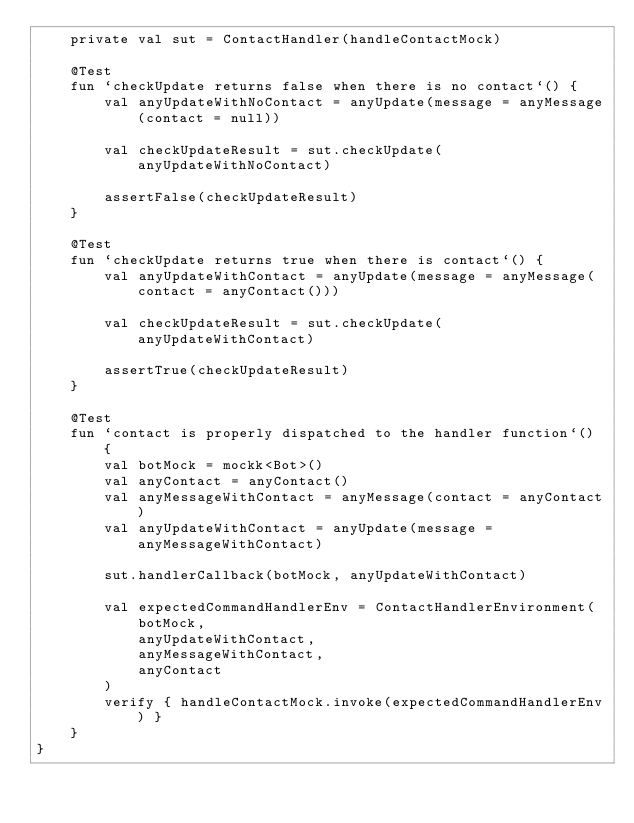Convert code to text. <code><loc_0><loc_0><loc_500><loc_500><_Kotlin_>    private val sut = ContactHandler(handleContactMock)

    @Test
    fun `checkUpdate returns false when there is no contact`() {
        val anyUpdateWithNoContact = anyUpdate(message = anyMessage(contact = null))

        val checkUpdateResult = sut.checkUpdate(anyUpdateWithNoContact)

        assertFalse(checkUpdateResult)
    }

    @Test
    fun `checkUpdate returns true when there is contact`() {
        val anyUpdateWithContact = anyUpdate(message = anyMessage(contact = anyContact()))

        val checkUpdateResult = sut.checkUpdate(anyUpdateWithContact)

        assertTrue(checkUpdateResult)
    }

    @Test
    fun `contact is properly dispatched to the handler function`() {
        val botMock = mockk<Bot>()
        val anyContact = anyContact()
        val anyMessageWithContact = anyMessage(contact = anyContact)
        val anyUpdateWithContact = anyUpdate(message = anyMessageWithContact)

        sut.handlerCallback(botMock, anyUpdateWithContact)

        val expectedCommandHandlerEnv = ContactHandlerEnvironment(
            botMock,
            anyUpdateWithContact,
            anyMessageWithContact,
            anyContact
        )
        verify { handleContactMock.invoke(expectedCommandHandlerEnv) }
    }
}
</code> 